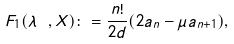Convert formula to latex. <formula><loc_0><loc_0><loc_500><loc_500>F _ { 1 } ( \lambda \ , X ) \colon = \frac { n ! } { 2 d } ( 2 a _ { n } - \mu a _ { n + 1 } ) ,</formula> 